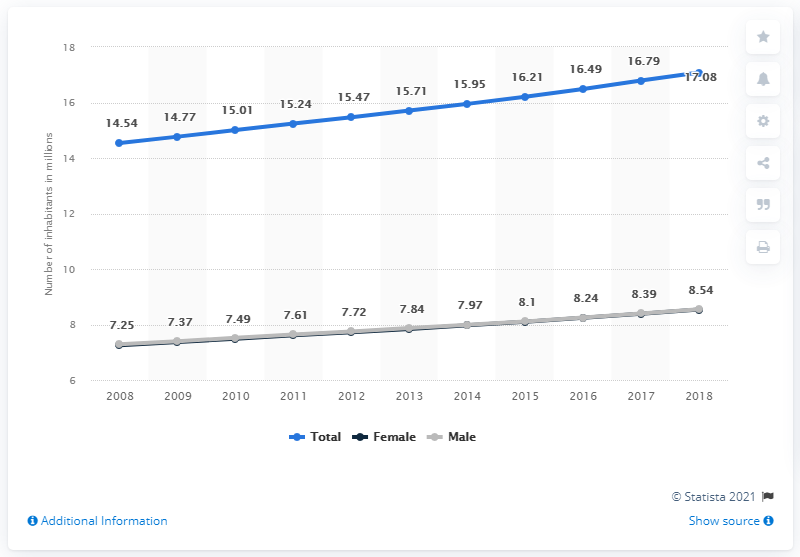List a handful of essential elements in this visual. In 2018, there were approximately 8.54 males living in Ecuador. In 2018, the estimated number of people living in Ecuador was 17,081,200. 